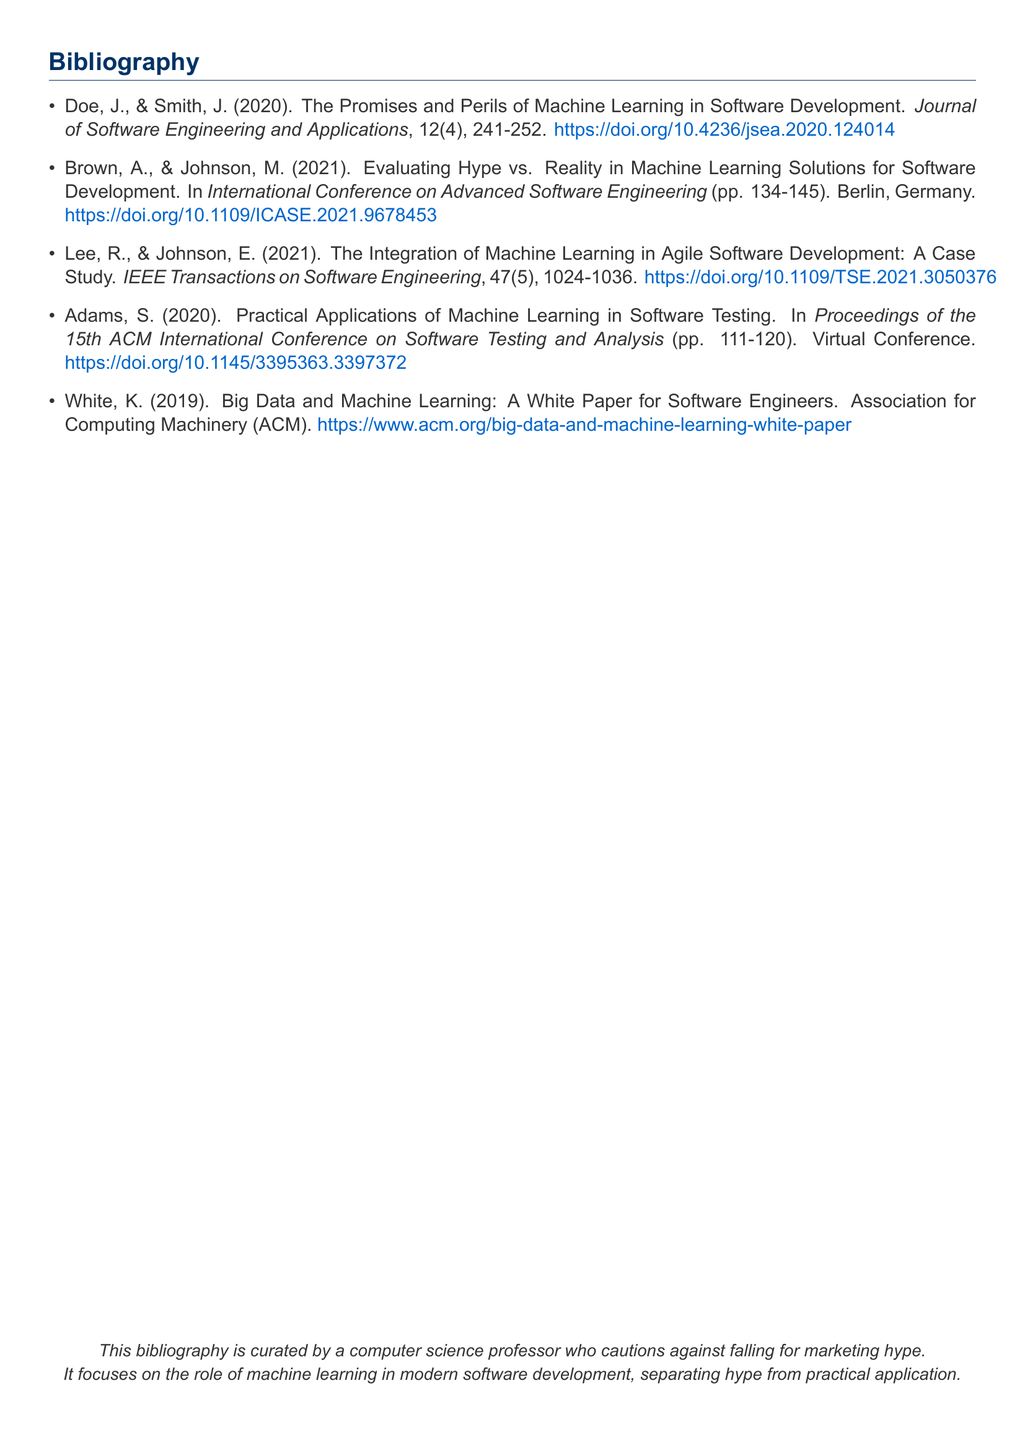What is the title of the first referenced article? The title is the name of the first article cited in the bibliography, which is provided directly in the document.
Answer: The Promises and Perils of Machine Learning in Software Development What year was the paper by Brown and Johnson published? The year is included in the reference entry for the paper by Brown and Johnson in the bibliography.
Answer: 2021 How many pages does the paper by Adams cover? The page range in the reference entry for the paper by Adams indicates the span of the publication.
Answer: 111-120 What type of event is the paper by Brown and Johnson associated with? The type of event is identified in the citation for Brown and Johnson's paper in the bibliography.
Answer: International Conference on Advanced Software Engineering Who is the sole author of the white paper? The white paper reference clearly names the author listed, which identifies the sole contributor to the document.
Answer: White, K 